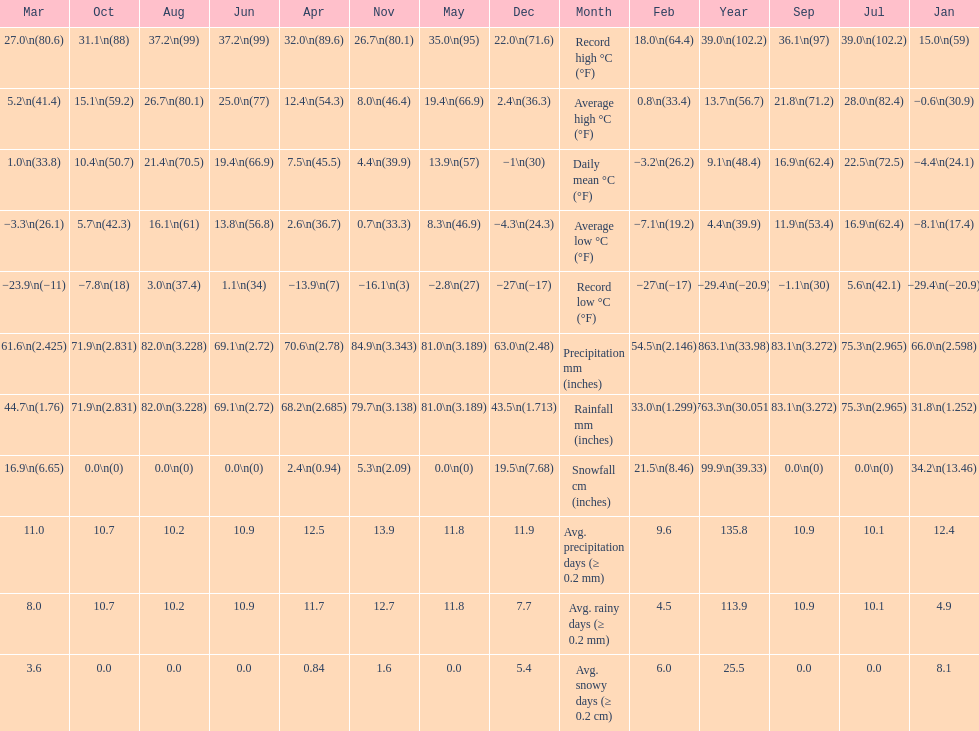How many months had a record high of over 15.0 degrees? 11. 